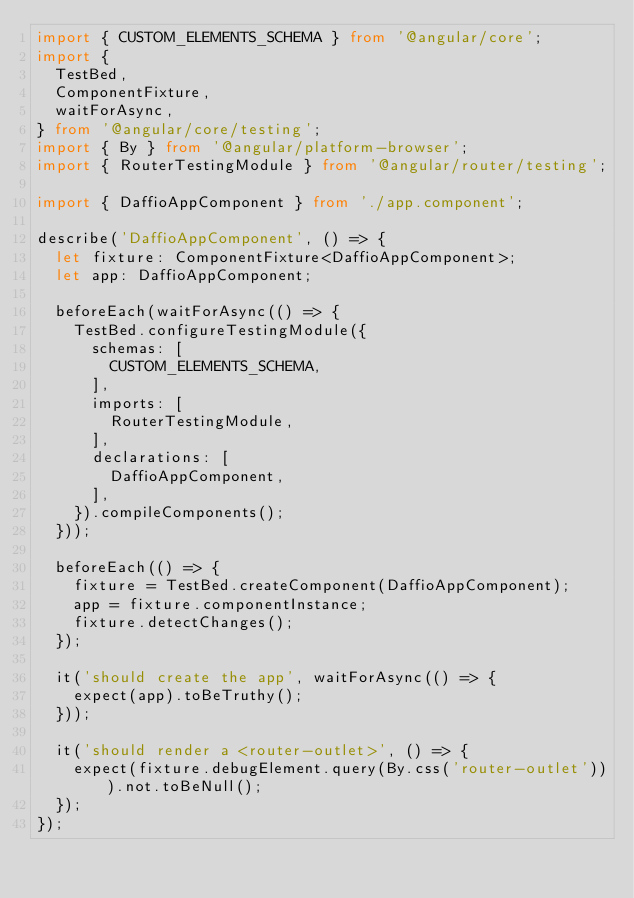<code> <loc_0><loc_0><loc_500><loc_500><_TypeScript_>import { CUSTOM_ELEMENTS_SCHEMA } from '@angular/core';
import {
  TestBed,
  ComponentFixture,
  waitForAsync,
} from '@angular/core/testing';
import { By } from '@angular/platform-browser';
import { RouterTestingModule } from '@angular/router/testing';

import { DaffioAppComponent } from './app.component';

describe('DaffioAppComponent', () => {
  let fixture: ComponentFixture<DaffioAppComponent>;
  let app: DaffioAppComponent;

  beforeEach(waitForAsync(() => {
    TestBed.configureTestingModule({
      schemas: [
        CUSTOM_ELEMENTS_SCHEMA,
      ],
      imports: [
        RouterTestingModule,
      ],
      declarations: [
        DaffioAppComponent,
      ],
    }).compileComponents();
  }));

  beforeEach(() => {
    fixture = TestBed.createComponent(DaffioAppComponent);
    app = fixture.componentInstance;
    fixture.detectChanges();
  });

  it('should create the app', waitForAsync(() => {
    expect(app).toBeTruthy();
  }));

  it('should render a <router-outlet>', () => {
    expect(fixture.debugElement.query(By.css('router-outlet'))).not.toBeNull();
  });
});
</code> 